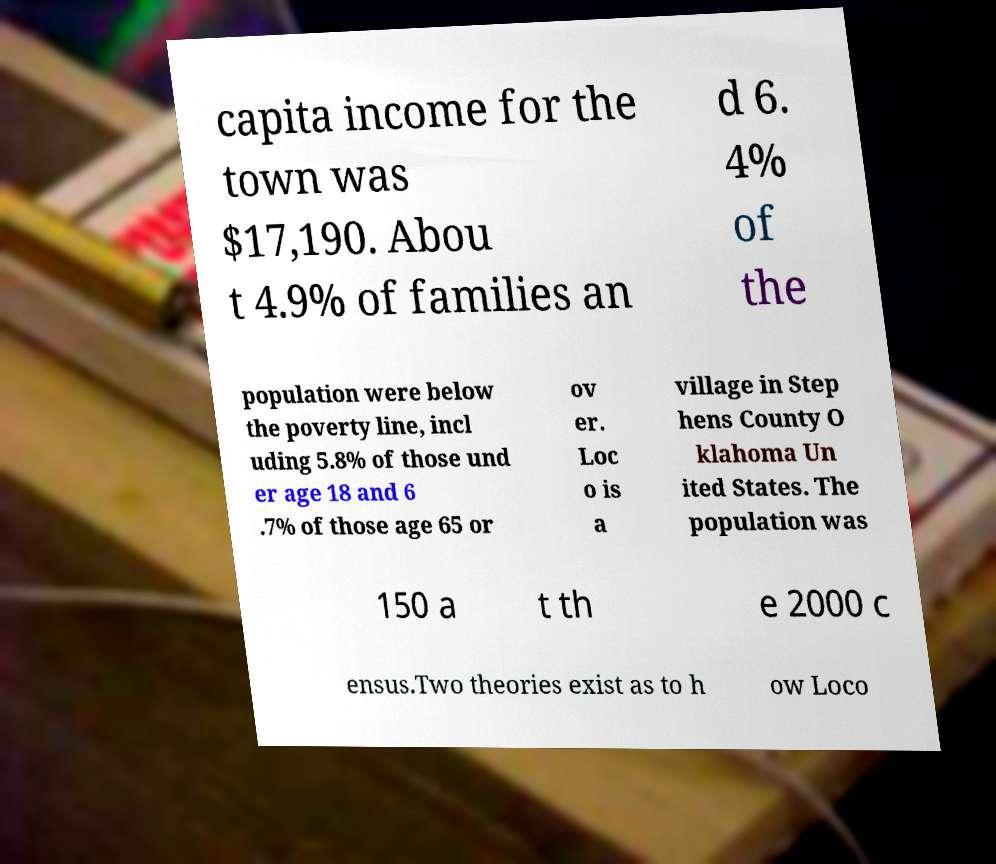Could you extract and type out the text from this image? capita income for the town was $17,190. Abou t 4.9% of families an d 6. 4% of the population were below the poverty line, incl uding 5.8% of those und er age 18 and 6 .7% of those age 65 or ov er. Loc o is a village in Step hens County O klahoma Un ited States. The population was 150 a t th e 2000 c ensus.Two theories exist as to h ow Loco 